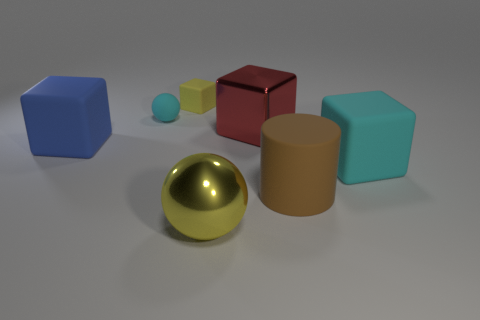Add 2 brown metallic spheres. How many objects exist? 9 Add 2 big blue things. How many big blue things exist? 3 Subtract 0 brown cubes. How many objects are left? 7 Subtract all cylinders. How many objects are left? 6 Subtract all metal spheres. Subtract all large metallic balls. How many objects are left? 5 Add 2 small cyan things. How many small cyan things are left? 3 